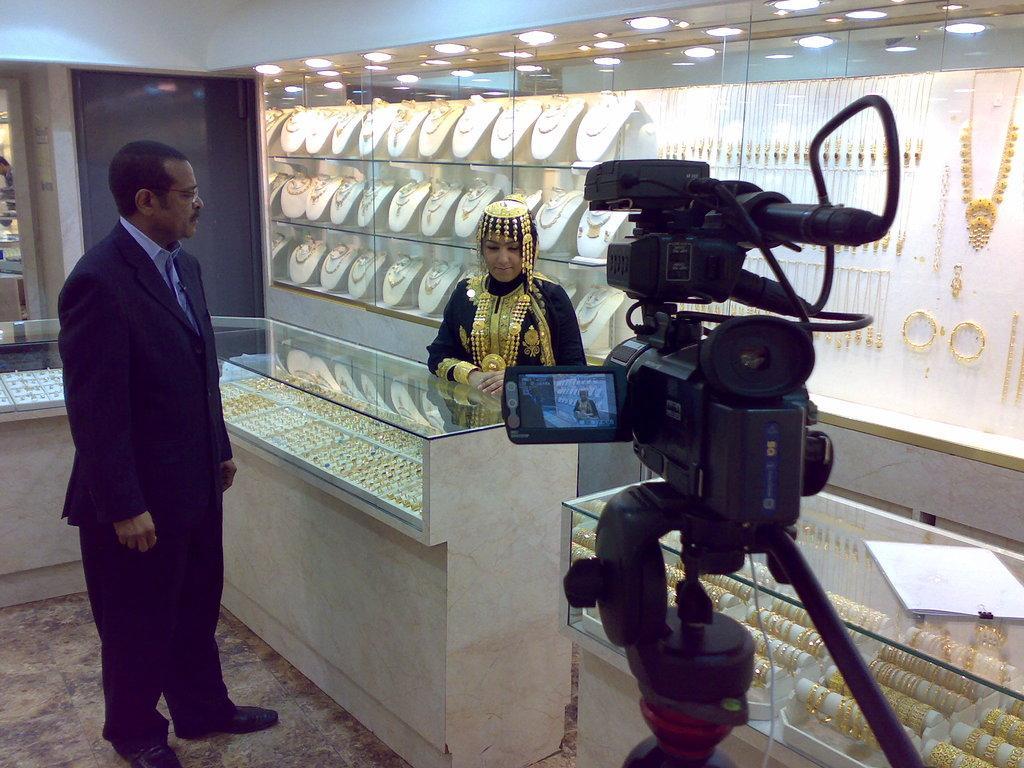Can you describe this image briefly? In this image I can see a person wearing black colored dress is standing and a woman wearing black colored dress and gold ornaments is standing. I can see few racks with gold ornaments in them. I can see the ceiling, few lights to the ceiling and a camera which is black in color. 